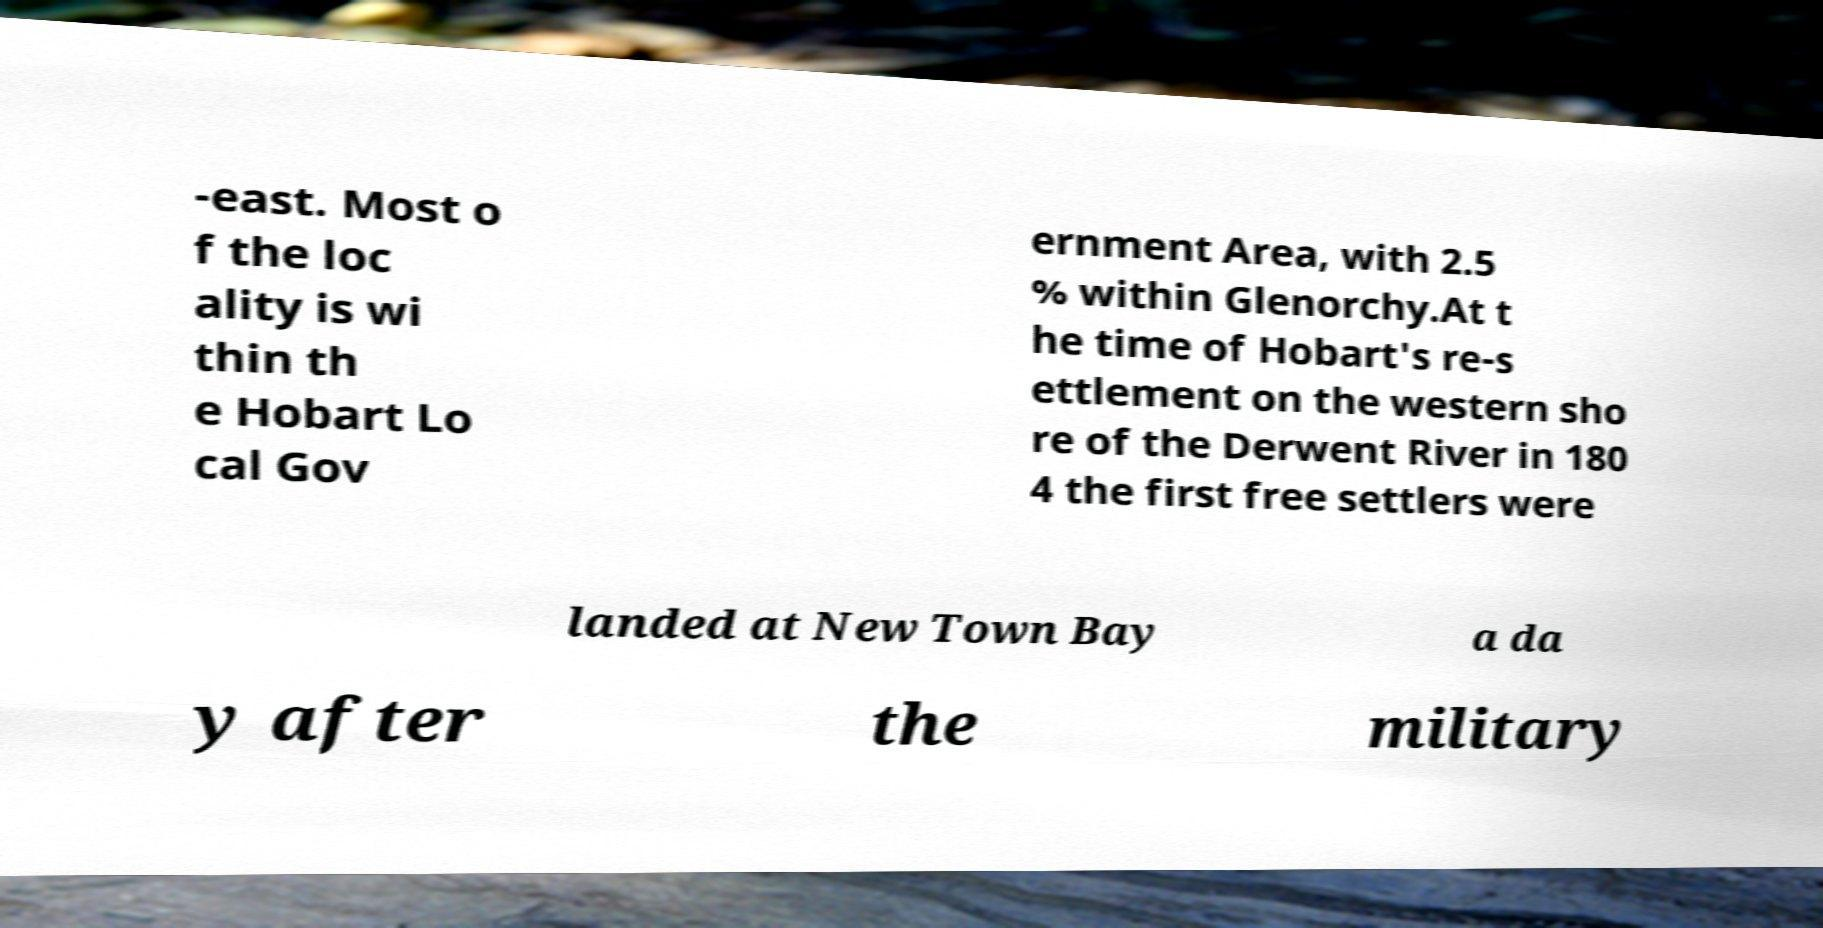There's text embedded in this image that I need extracted. Can you transcribe it verbatim? -east. Most o f the loc ality is wi thin th e Hobart Lo cal Gov ernment Area, with 2.5 % within Glenorchy.At t he time of Hobart's re-s ettlement on the western sho re of the Derwent River in 180 4 the first free settlers were landed at New Town Bay a da y after the military 